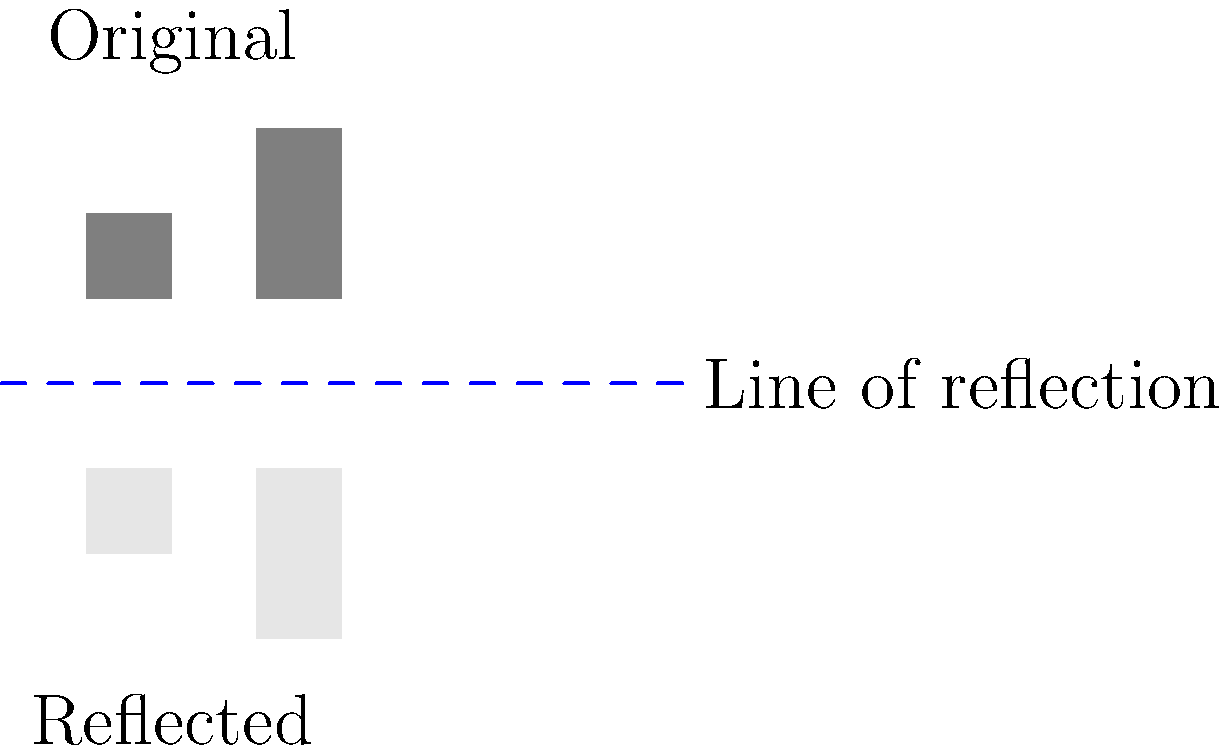In the process of designing a new military-civilian shared space, you decide to reflect the layout of historical buildings across a line to create a symmetrical design. If the coordinates of two key buildings in the original layout are $(-1.5, 1)$ and $(0, 1.5)$, what are the coordinates of their reflections across the x-axis? To find the coordinates of the reflected buildings, we follow these steps:

1. Identify the line of reflection: In this case, it's the x-axis (y = 0).

2. For reflection across the x-axis, the x-coordinate remains the same, while the y-coordinate changes sign.

3. For the first building at $(-1.5, 1)$:
   - x-coordinate: -1.5 (remains the same)
   - y-coordinate: 1 becomes -1
   New coordinates: $(-1.5, -1)$

4. For the second building at $(0, 1.5)$:
   - x-coordinate: 0 (remains the same)
   - y-coordinate: 1.5 becomes -1.5
   New coordinates: $(0, -1.5)$

Therefore, the reflected coordinates are $(-1.5, -1)$ and $(0, -1.5)$.
Answer: $(-1.5, -1)$ and $(0, -1.5)$ 